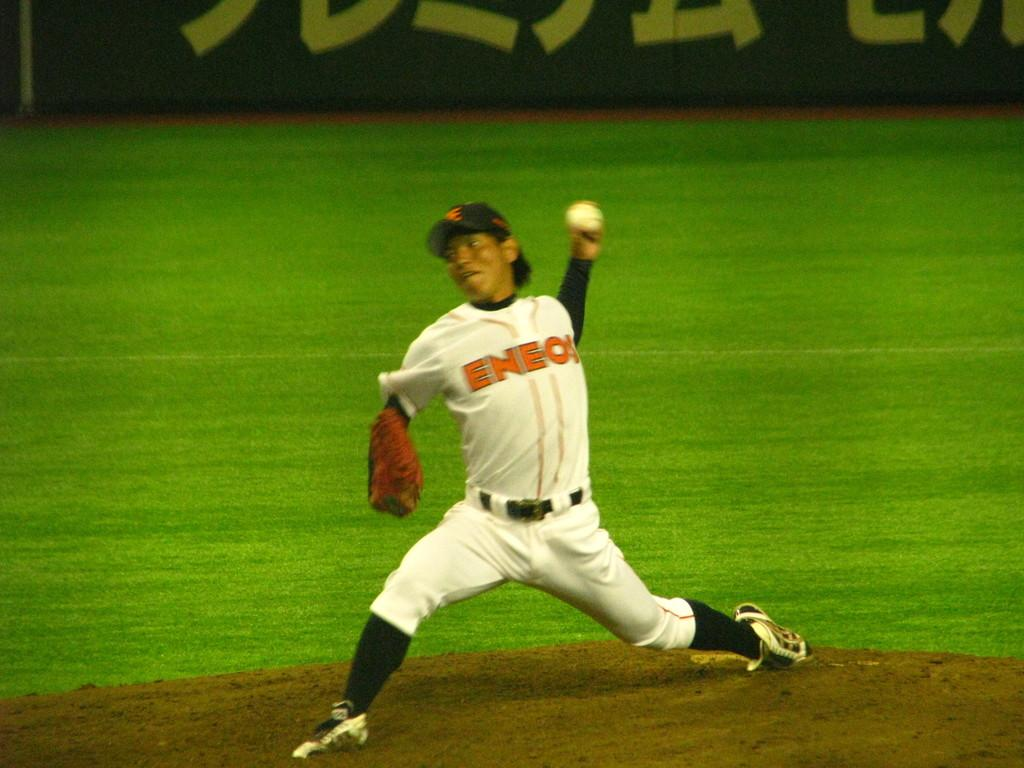Provide a one-sentence caption for the provided image. The Eneos pitcher is just about to release the baseball. 